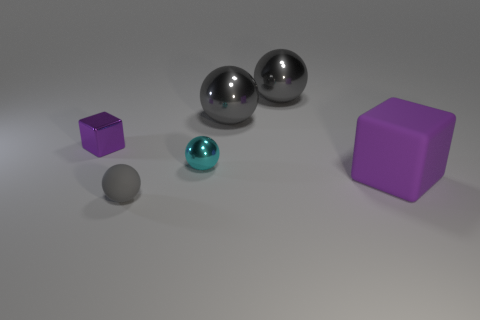Subtract all yellow cylinders. How many gray spheres are left? 3 Add 3 big rubber spheres. How many objects exist? 9 Subtract all blocks. How many objects are left? 4 Add 2 cyan objects. How many cyan objects exist? 3 Subtract 0 yellow balls. How many objects are left? 6 Subtract all gray balls. Subtract all purple rubber blocks. How many objects are left? 2 Add 2 tiny purple metal objects. How many tiny purple metal objects are left? 3 